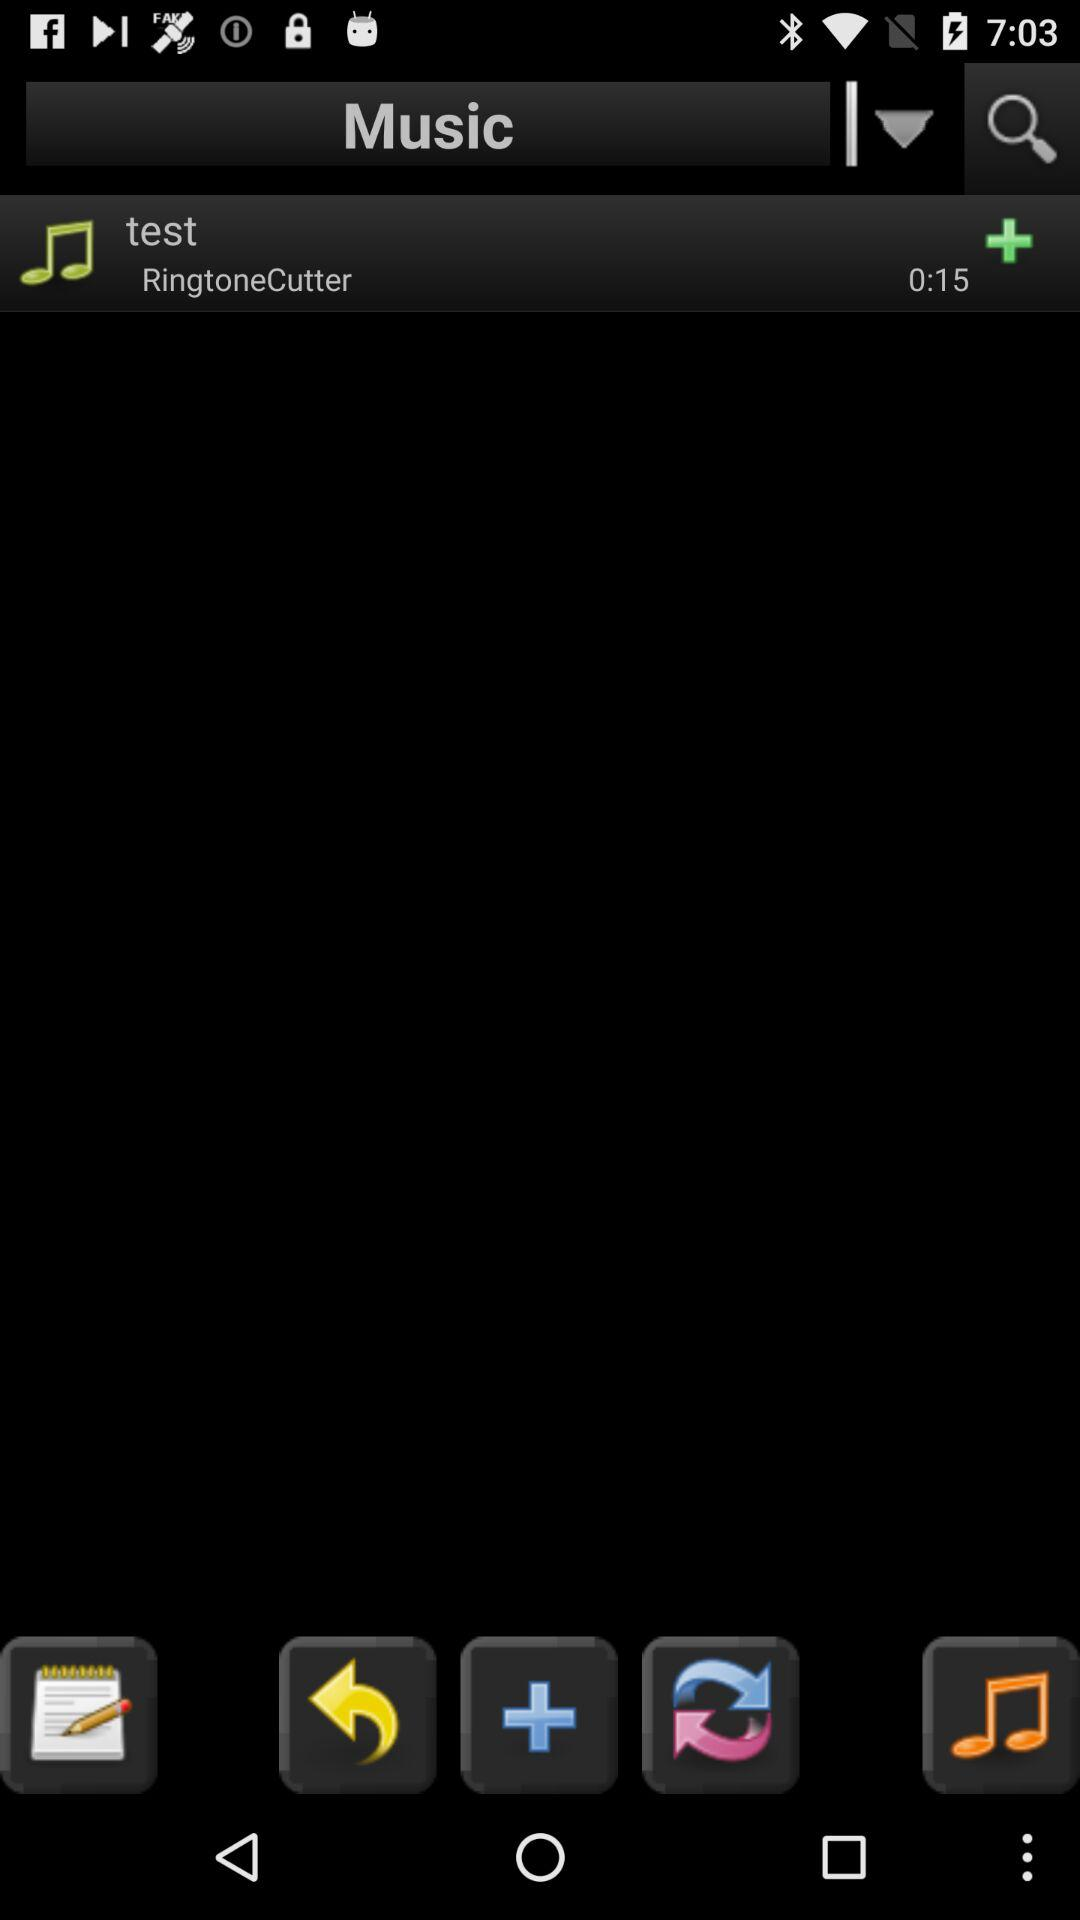What is the name of the ringtone? The name of the ringtone is "test". 